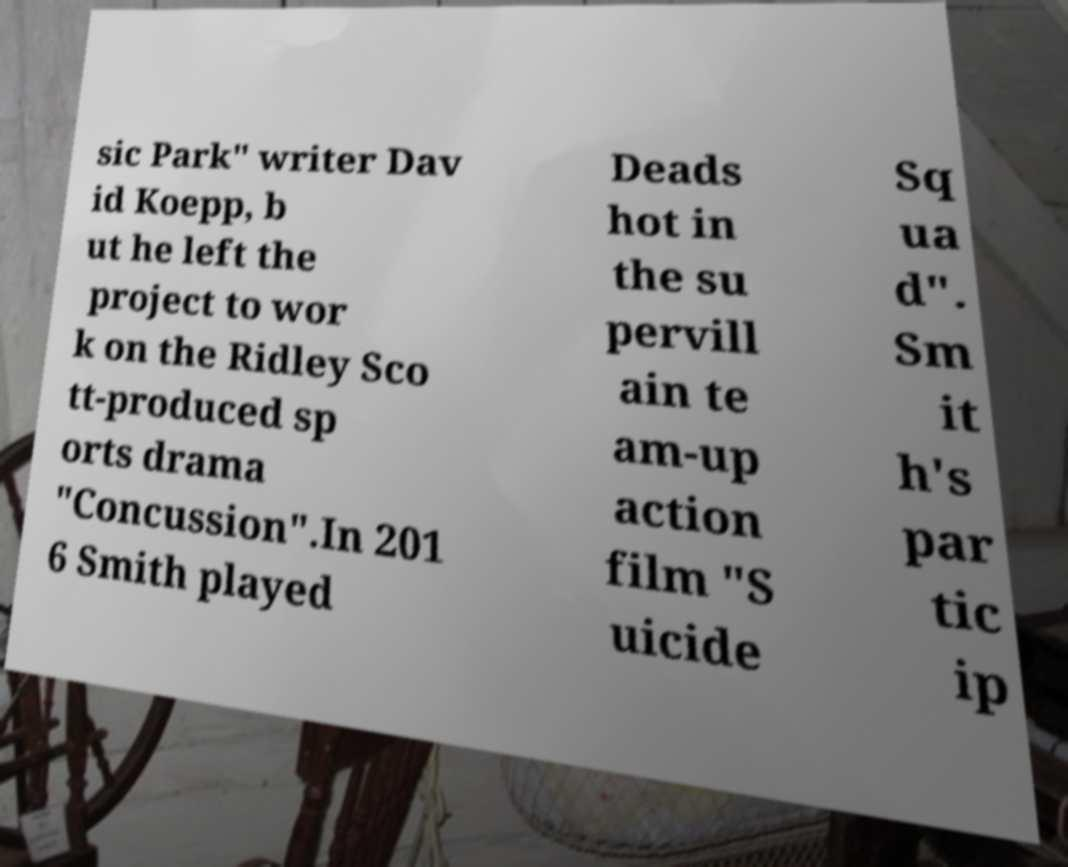Can you read and provide the text displayed in the image?This photo seems to have some interesting text. Can you extract and type it out for me? sic Park" writer Dav id Koepp, b ut he left the project to wor k on the Ridley Sco tt-produced sp orts drama "Concussion".In 201 6 Smith played Deads hot in the su pervill ain te am-up action film "S uicide Sq ua d". Sm it h's par tic ip 